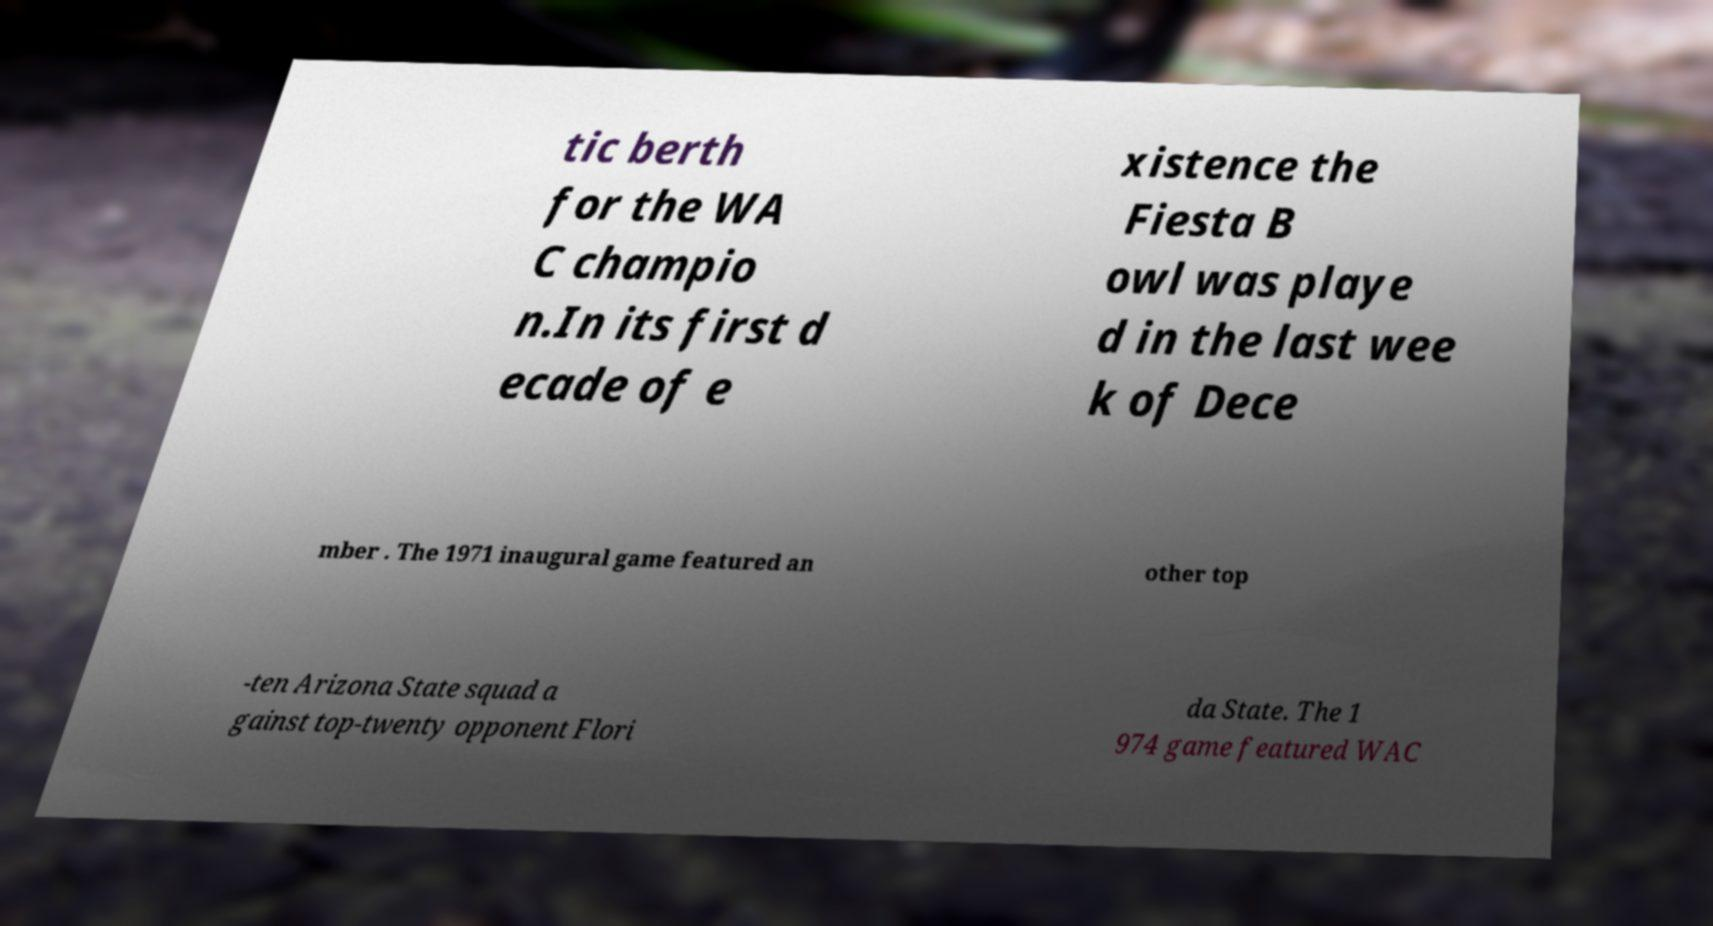Please identify and transcribe the text found in this image. tic berth for the WA C champio n.In its first d ecade of e xistence the Fiesta B owl was playe d in the last wee k of Dece mber . The 1971 inaugural game featured an other top -ten Arizona State squad a gainst top-twenty opponent Flori da State. The 1 974 game featured WAC 